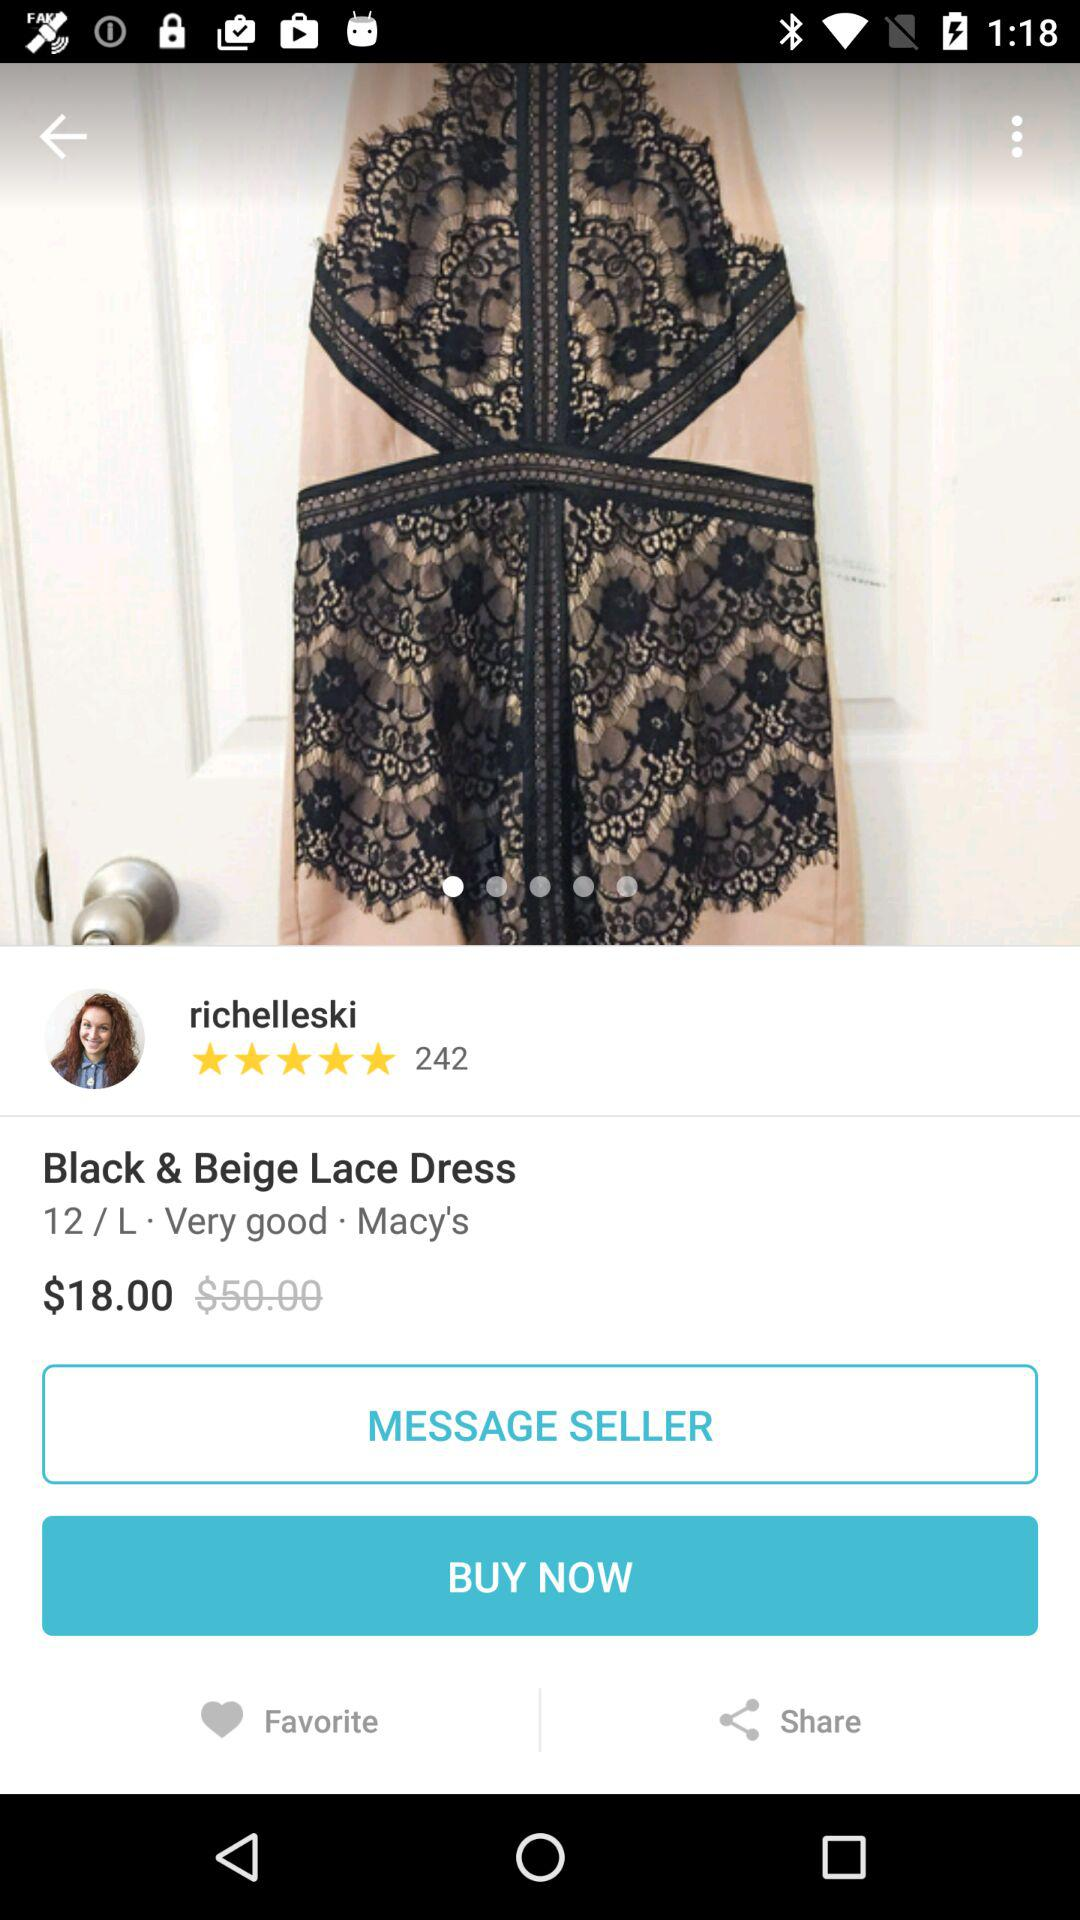How many reviews are there for this dress? There are 242 reviews. 